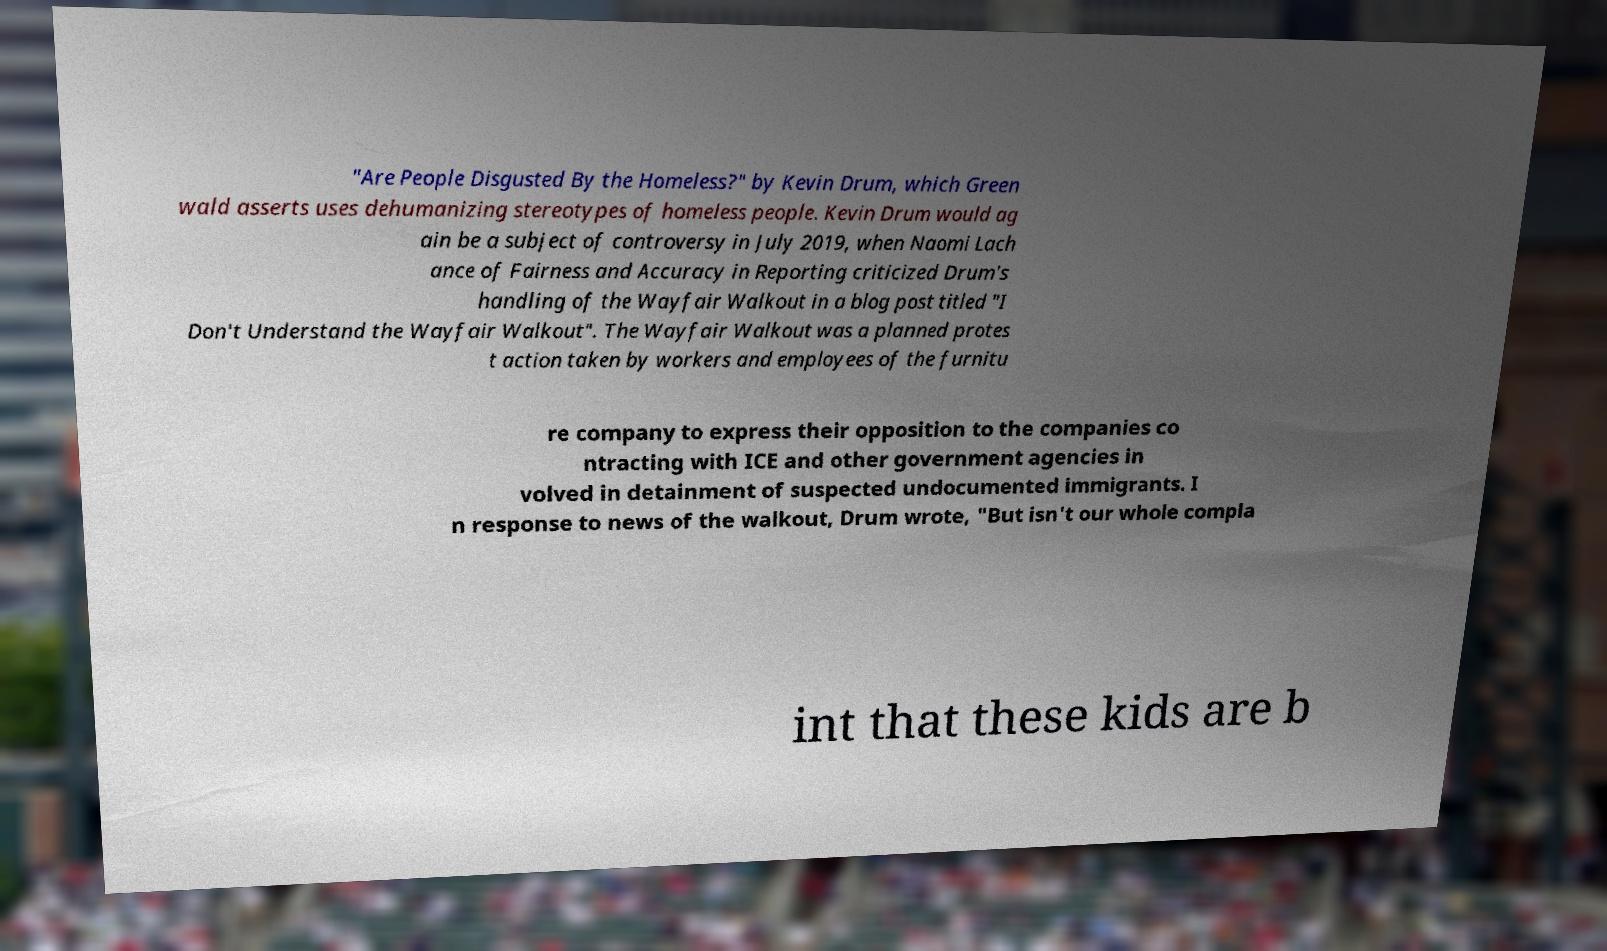For documentation purposes, I need the text within this image transcribed. Could you provide that? "Are People Disgusted By the Homeless?" by Kevin Drum, which Green wald asserts uses dehumanizing stereotypes of homeless people. Kevin Drum would ag ain be a subject of controversy in July 2019, when Naomi Lach ance of Fairness and Accuracy in Reporting criticized Drum's handling of the Wayfair Walkout in a blog post titled "I Don't Understand the Wayfair Walkout". The Wayfair Walkout was a planned protes t action taken by workers and employees of the furnitu re company to express their opposition to the companies co ntracting with ICE and other government agencies in volved in detainment of suspected undocumented immigrants. I n response to news of the walkout, Drum wrote, "But isn't our whole compla int that these kids are b 